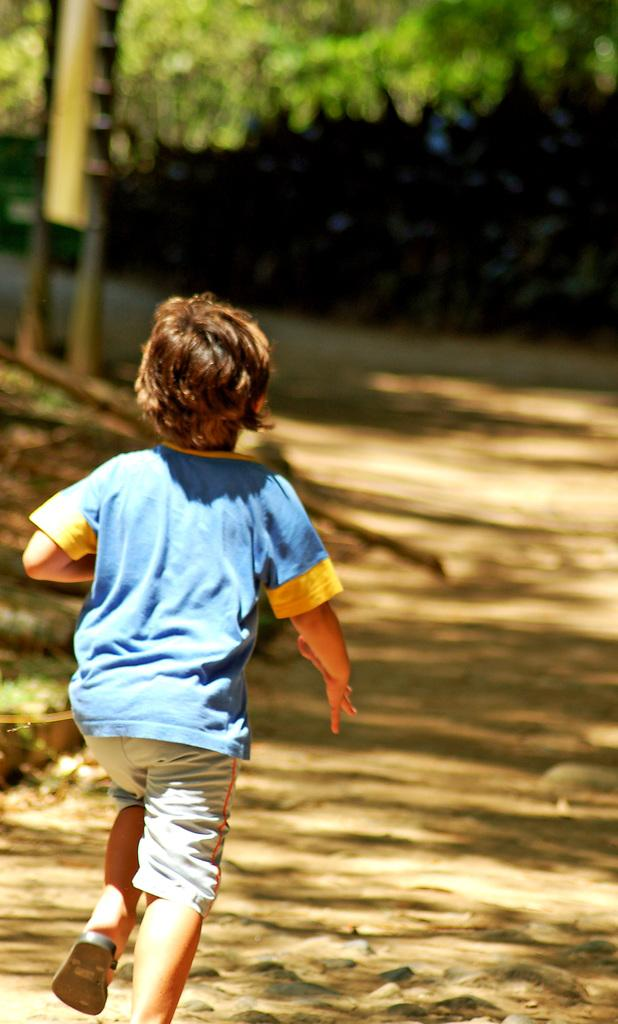Who is the main subject in the image? There is a boy in the image. What is the boy doing in the image? The boy is running in the image. On what surface is the boy running? The boy is running on sand in the image. What type of vegetation can be seen at the top of the image? There are green leaves visible at the top of the image. What type of terrain is visible at the bottom of the image? There is sand visible at the bottom of the image. How many dimes are scattered on the sand in the image? There are no dimes visible in the image; it only shows a boy running on sand. What type of pizzas can be seen being served in the image? There are no pizzas present in the image; it only features a boy running on sand. 